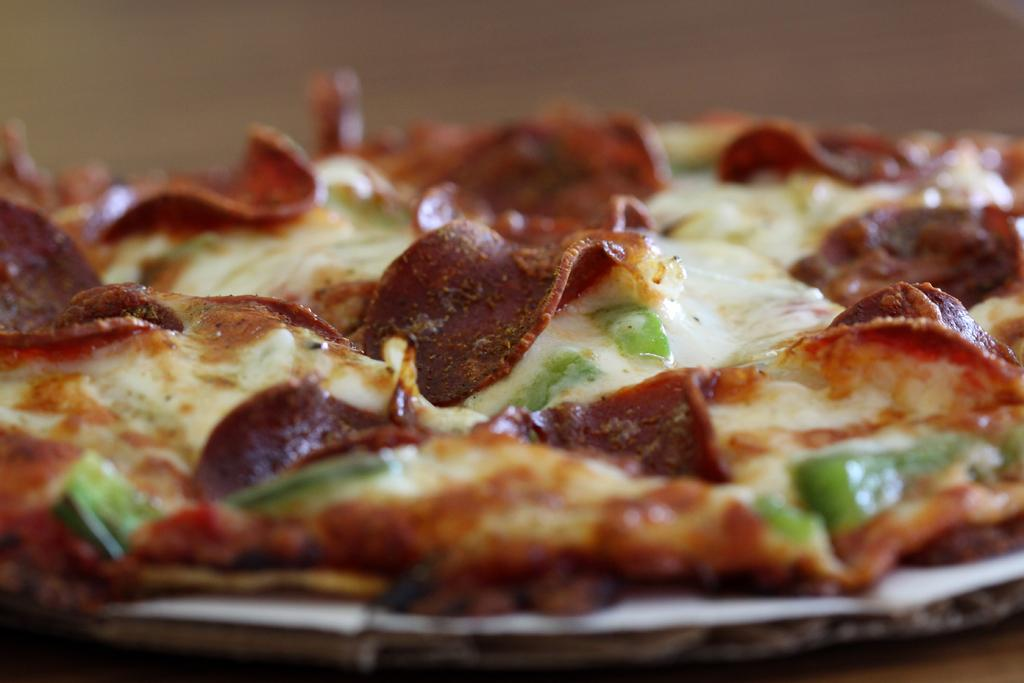What type of food is the main subject of the image? There is a pizza in the image. What type of bears can be seen eating the pizza in the image? There are no bears present in the image; it only features a pizza. 